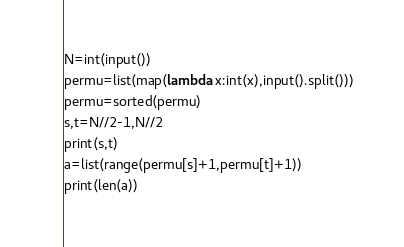<code> <loc_0><loc_0><loc_500><loc_500><_Python_>N=int(input())
permu=list(map(lambda x:int(x),input().split()))
permu=sorted(permu)
s,t=N//2-1,N//2
print(s,t)
a=list(range(permu[s]+1,permu[t]+1))
print(len(a))
</code> 